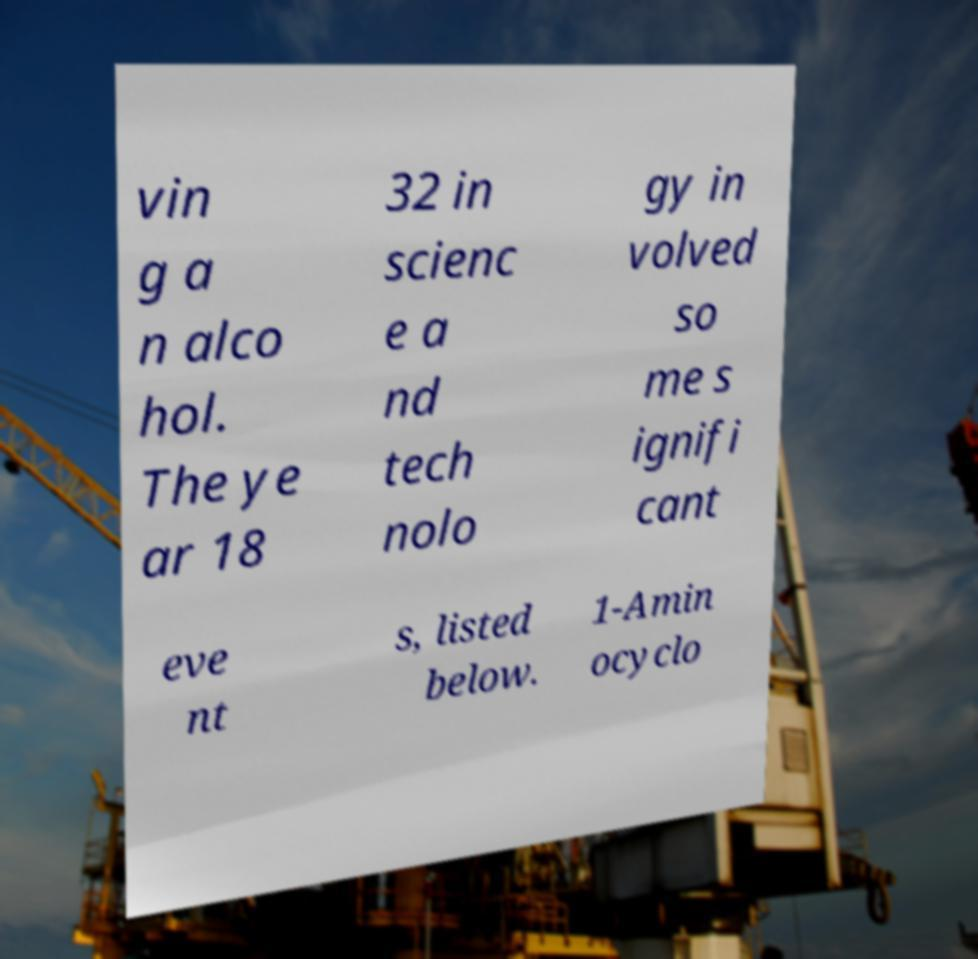Please read and relay the text visible in this image. What does it say? vin g a n alco hol. The ye ar 18 32 in scienc e a nd tech nolo gy in volved so me s ignifi cant eve nt s, listed below. 1-Amin ocyclo 